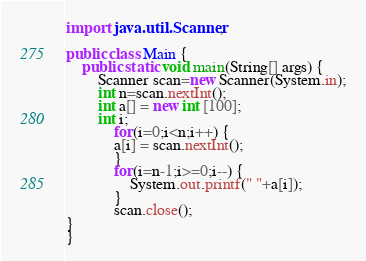Convert code to text. <code><loc_0><loc_0><loc_500><loc_500><_Java_>import java.util.Scanner;

public class Main {
	public static void main(String[] args) {
		Scanner scan=new Scanner(System.in);
		int n=scan.nextInt();
		int a[] = new int [100];
		int i;
			for(i=0;i<n;i++) {
			a[i] = scan.nextInt();
			}
			for(i=n-1;i>=0;i--) {
				System.out.printf(" "+a[i]);
			}
			scan.close();
}
}
</code> 